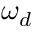Convert formula to latex. <formula><loc_0><loc_0><loc_500><loc_500>\omega _ { d }</formula> 